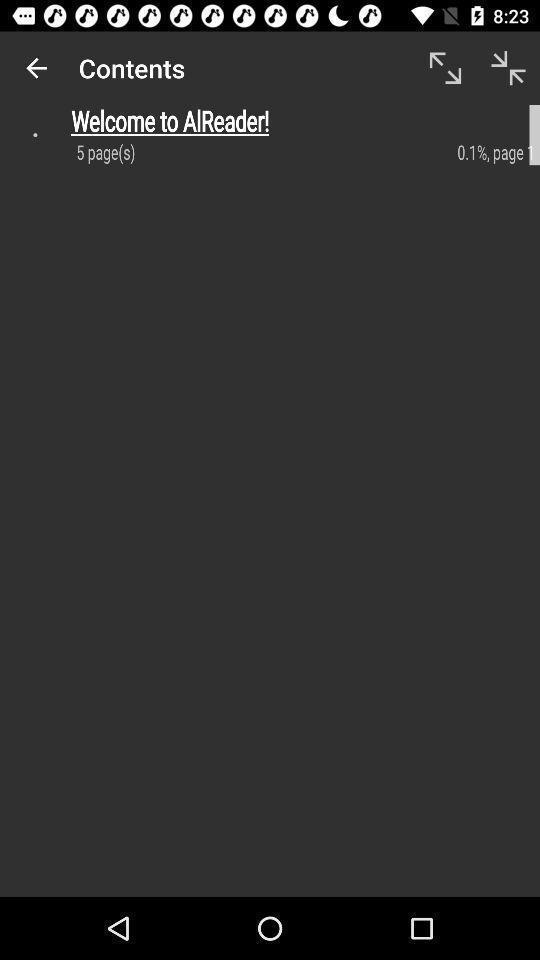What can you discern from this picture? Welcome page of social app. 